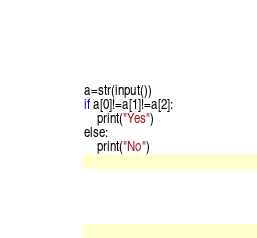<code> <loc_0><loc_0><loc_500><loc_500><_C_>a=str(input())
if a[0]!=a[1]!=a[2]:
    print("Yes")
else:
    print("No")</code> 